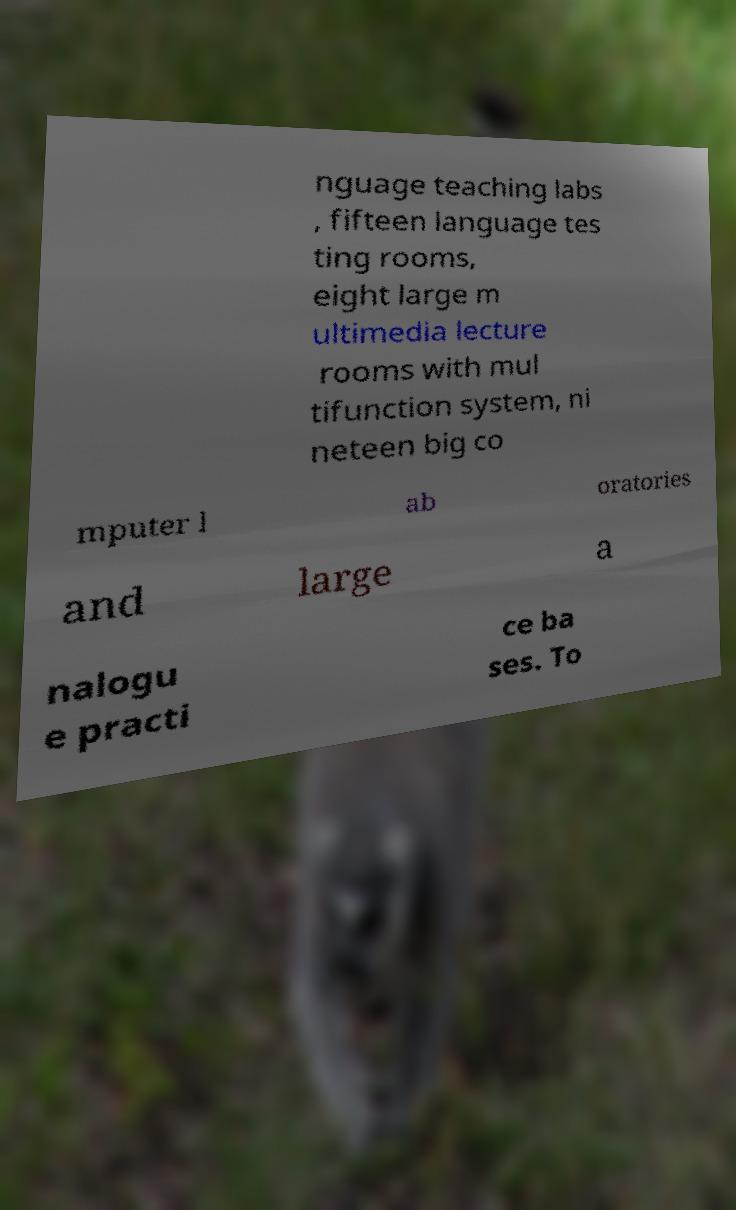What messages or text are displayed in this image? I need them in a readable, typed format. nguage teaching labs , fifteen language tes ting rooms, eight large m ultimedia lecture rooms with mul tifunction system, ni neteen big co mputer l ab oratories and large a nalogu e practi ce ba ses. To 